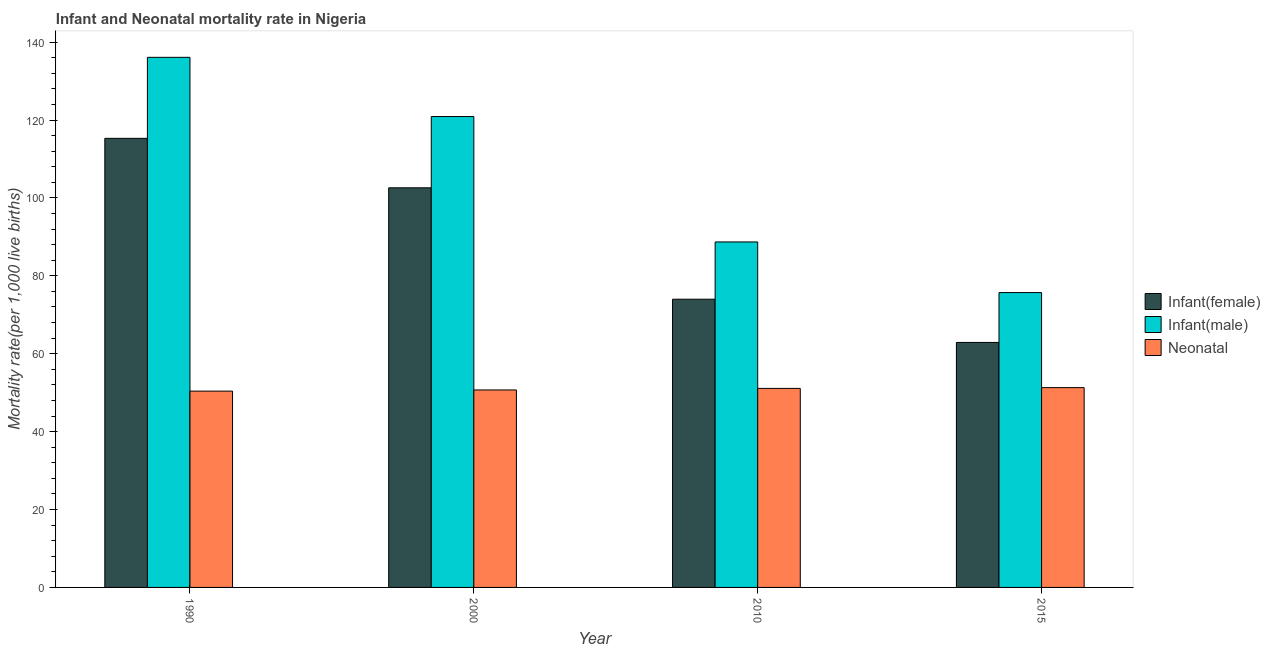How many different coloured bars are there?
Offer a very short reply. 3. How many groups of bars are there?
Ensure brevity in your answer.  4. Are the number of bars per tick equal to the number of legend labels?
Your answer should be very brief. Yes. Are the number of bars on each tick of the X-axis equal?
Provide a short and direct response. Yes. How many bars are there on the 3rd tick from the left?
Your response must be concise. 3. What is the infant mortality rate(female) in 2000?
Offer a very short reply. 102.6. Across all years, what is the maximum neonatal mortality rate?
Keep it short and to the point. 51.3. Across all years, what is the minimum infant mortality rate(male)?
Your response must be concise. 75.7. In which year was the infant mortality rate(female) minimum?
Offer a very short reply. 2015. What is the total infant mortality rate(female) in the graph?
Make the answer very short. 354.8. What is the difference between the infant mortality rate(female) in 2010 and that in 2015?
Ensure brevity in your answer.  11.1. What is the difference between the neonatal mortality rate in 2010 and the infant mortality rate(male) in 1990?
Keep it short and to the point. 0.7. What is the average infant mortality rate(female) per year?
Provide a short and direct response. 88.7. In the year 2015, what is the difference between the infant mortality rate(female) and neonatal mortality rate?
Your answer should be very brief. 0. In how many years, is the infant mortality rate(female) greater than 128?
Offer a very short reply. 0. What is the ratio of the infant mortality rate(male) in 1990 to that in 2010?
Your response must be concise. 1.53. What is the difference between the highest and the second highest infant mortality rate(male)?
Ensure brevity in your answer.  15.2. What is the difference between the highest and the lowest neonatal mortality rate?
Your answer should be compact. 0.9. What does the 2nd bar from the left in 2000 represents?
Keep it short and to the point. Infant(male). What does the 3rd bar from the right in 1990 represents?
Your answer should be compact. Infant(female). How many years are there in the graph?
Give a very brief answer. 4. Are the values on the major ticks of Y-axis written in scientific E-notation?
Your response must be concise. No. What is the title of the graph?
Make the answer very short. Infant and Neonatal mortality rate in Nigeria. Does "Fuel" appear as one of the legend labels in the graph?
Your response must be concise. No. What is the label or title of the Y-axis?
Give a very brief answer. Mortality rate(per 1,0 live births). What is the Mortality rate(per 1,000 live births) of Infant(female) in 1990?
Offer a terse response. 115.3. What is the Mortality rate(per 1,000 live births) of Infant(male) in 1990?
Provide a succinct answer. 136.1. What is the Mortality rate(per 1,000 live births) of Neonatal  in 1990?
Your answer should be compact. 50.4. What is the Mortality rate(per 1,000 live births) in Infant(female) in 2000?
Your answer should be very brief. 102.6. What is the Mortality rate(per 1,000 live births) in Infant(male) in 2000?
Provide a succinct answer. 120.9. What is the Mortality rate(per 1,000 live births) in Neonatal  in 2000?
Make the answer very short. 50.7. What is the Mortality rate(per 1,000 live births) in Infant(female) in 2010?
Offer a very short reply. 74. What is the Mortality rate(per 1,000 live births) in Infant(male) in 2010?
Your answer should be very brief. 88.7. What is the Mortality rate(per 1,000 live births) of Neonatal  in 2010?
Keep it short and to the point. 51.1. What is the Mortality rate(per 1,000 live births) in Infant(female) in 2015?
Provide a succinct answer. 62.9. What is the Mortality rate(per 1,000 live births) in Infant(male) in 2015?
Keep it short and to the point. 75.7. What is the Mortality rate(per 1,000 live births) of Neonatal  in 2015?
Your answer should be compact. 51.3. Across all years, what is the maximum Mortality rate(per 1,000 live births) in Infant(female)?
Offer a terse response. 115.3. Across all years, what is the maximum Mortality rate(per 1,000 live births) of Infant(male)?
Your answer should be compact. 136.1. Across all years, what is the maximum Mortality rate(per 1,000 live births) in Neonatal ?
Your response must be concise. 51.3. Across all years, what is the minimum Mortality rate(per 1,000 live births) of Infant(female)?
Keep it short and to the point. 62.9. Across all years, what is the minimum Mortality rate(per 1,000 live births) of Infant(male)?
Your answer should be compact. 75.7. Across all years, what is the minimum Mortality rate(per 1,000 live births) in Neonatal ?
Provide a succinct answer. 50.4. What is the total Mortality rate(per 1,000 live births) of Infant(female) in the graph?
Keep it short and to the point. 354.8. What is the total Mortality rate(per 1,000 live births) in Infant(male) in the graph?
Your answer should be very brief. 421.4. What is the total Mortality rate(per 1,000 live births) in Neonatal  in the graph?
Your answer should be compact. 203.5. What is the difference between the Mortality rate(per 1,000 live births) of Neonatal  in 1990 and that in 2000?
Offer a very short reply. -0.3. What is the difference between the Mortality rate(per 1,000 live births) in Infant(female) in 1990 and that in 2010?
Provide a short and direct response. 41.3. What is the difference between the Mortality rate(per 1,000 live births) of Infant(male) in 1990 and that in 2010?
Your answer should be compact. 47.4. What is the difference between the Mortality rate(per 1,000 live births) of Infant(female) in 1990 and that in 2015?
Your answer should be very brief. 52.4. What is the difference between the Mortality rate(per 1,000 live births) in Infant(male) in 1990 and that in 2015?
Offer a terse response. 60.4. What is the difference between the Mortality rate(per 1,000 live births) in Infant(female) in 2000 and that in 2010?
Provide a short and direct response. 28.6. What is the difference between the Mortality rate(per 1,000 live births) of Infant(male) in 2000 and that in 2010?
Your response must be concise. 32.2. What is the difference between the Mortality rate(per 1,000 live births) in Infant(female) in 2000 and that in 2015?
Keep it short and to the point. 39.7. What is the difference between the Mortality rate(per 1,000 live births) of Infant(male) in 2000 and that in 2015?
Keep it short and to the point. 45.2. What is the difference between the Mortality rate(per 1,000 live births) in Infant(female) in 2010 and that in 2015?
Offer a terse response. 11.1. What is the difference between the Mortality rate(per 1,000 live births) in Infant(male) in 2010 and that in 2015?
Your response must be concise. 13. What is the difference between the Mortality rate(per 1,000 live births) in Neonatal  in 2010 and that in 2015?
Your response must be concise. -0.2. What is the difference between the Mortality rate(per 1,000 live births) in Infant(female) in 1990 and the Mortality rate(per 1,000 live births) in Infant(male) in 2000?
Your response must be concise. -5.6. What is the difference between the Mortality rate(per 1,000 live births) of Infant(female) in 1990 and the Mortality rate(per 1,000 live births) of Neonatal  in 2000?
Keep it short and to the point. 64.6. What is the difference between the Mortality rate(per 1,000 live births) of Infant(male) in 1990 and the Mortality rate(per 1,000 live births) of Neonatal  in 2000?
Keep it short and to the point. 85.4. What is the difference between the Mortality rate(per 1,000 live births) of Infant(female) in 1990 and the Mortality rate(per 1,000 live births) of Infant(male) in 2010?
Provide a short and direct response. 26.6. What is the difference between the Mortality rate(per 1,000 live births) of Infant(female) in 1990 and the Mortality rate(per 1,000 live births) of Neonatal  in 2010?
Your answer should be very brief. 64.2. What is the difference between the Mortality rate(per 1,000 live births) of Infant(female) in 1990 and the Mortality rate(per 1,000 live births) of Infant(male) in 2015?
Ensure brevity in your answer.  39.6. What is the difference between the Mortality rate(per 1,000 live births) in Infant(male) in 1990 and the Mortality rate(per 1,000 live births) in Neonatal  in 2015?
Keep it short and to the point. 84.8. What is the difference between the Mortality rate(per 1,000 live births) of Infant(female) in 2000 and the Mortality rate(per 1,000 live births) of Infant(male) in 2010?
Provide a succinct answer. 13.9. What is the difference between the Mortality rate(per 1,000 live births) in Infant(female) in 2000 and the Mortality rate(per 1,000 live births) in Neonatal  in 2010?
Make the answer very short. 51.5. What is the difference between the Mortality rate(per 1,000 live births) in Infant(male) in 2000 and the Mortality rate(per 1,000 live births) in Neonatal  in 2010?
Your answer should be compact. 69.8. What is the difference between the Mortality rate(per 1,000 live births) in Infant(female) in 2000 and the Mortality rate(per 1,000 live births) in Infant(male) in 2015?
Give a very brief answer. 26.9. What is the difference between the Mortality rate(per 1,000 live births) of Infant(female) in 2000 and the Mortality rate(per 1,000 live births) of Neonatal  in 2015?
Offer a terse response. 51.3. What is the difference between the Mortality rate(per 1,000 live births) in Infant(male) in 2000 and the Mortality rate(per 1,000 live births) in Neonatal  in 2015?
Give a very brief answer. 69.6. What is the difference between the Mortality rate(per 1,000 live births) of Infant(female) in 2010 and the Mortality rate(per 1,000 live births) of Infant(male) in 2015?
Provide a succinct answer. -1.7. What is the difference between the Mortality rate(per 1,000 live births) of Infant(female) in 2010 and the Mortality rate(per 1,000 live births) of Neonatal  in 2015?
Ensure brevity in your answer.  22.7. What is the difference between the Mortality rate(per 1,000 live births) of Infant(male) in 2010 and the Mortality rate(per 1,000 live births) of Neonatal  in 2015?
Give a very brief answer. 37.4. What is the average Mortality rate(per 1,000 live births) of Infant(female) per year?
Your answer should be compact. 88.7. What is the average Mortality rate(per 1,000 live births) of Infant(male) per year?
Offer a terse response. 105.35. What is the average Mortality rate(per 1,000 live births) in Neonatal  per year?
Offer a terse response. 50.88. In the year 1990, what is the difference between the Mortality rate(per 1,000 live births) of Infant(female) and Mortality rate(per 1,000 live births) of Infant(male)?
Ensure brevity in your answer.  -20.8. In the year 1990, what is the difference between the Mortality rate(per 1,000 live births) of Infant(female) and Mortality rate(per 1,000 live births) of Neonatal ?
Your response must be concise. 64.9. In the year 1990, what is the difference between the Mortality rate(per 1,000 live births) of Infant(male) and Mortality rate(per 1,000 live births) of Neonatal ?
Your response must be concise. 85.7. In the year 2000, what is the difference between the Mortality rate(per 1,000 live births) in Infant(female) and Mortality rate(per 1,000 live births) in Infant(male)?
Offer a terse response. -18.3. In the year 2000, what is the difference between the Mortality rate(per 1,000 live births) in Infant(female) and Mortality rate(per 1,000 live births) in Neonatal ?
Provide a short and direct response. 51.9. In the year 2000, what is the difference between the Mortality rate(per 1,000 live births) in Infant(male) and Mortality rate(per 1,000 live births) in Neonatal ?
Your response must be concise. 70.2. In the year 2010, what is the difference between the Mortality rate(per 1,000 live births) of Infant(female) and Mortality rate(per 1,000 live births) of Infant(male)?
Your answer should be very brief. -14.7. In the year 2010, what is the difference between the Mortality rate(per 1,000 live births) in Infant(female) and Mortality rate(per 1,000 live births) in Neonatal ?
Make the answer very short. 22.9. In the year 2010, what is the difference between the Mortality rate(per 1,000 live births) in Infant(male) and Mortality rate(per 1,000 live births) in Neonatal ?
Ensure brevity in your answer.  37.6. In the year 2015, what is the difference between the Mortality rate(per 1,000 live births) of Infant(male) and Mortality rate(per 1,000 live births) of Neonatal ?
Ensure brevity in your answer.  24.4. What is the ratio of the Mortality rate(per 1,000 live births) in Infant(female) in 1990 to that in 2000?
Ensure brevity in your answer.  1.12. What is the ratio of the Mortality rate(per 1,000 live births) in Infant(male) in 1990 to that in 2000?
Your answer should be compact. 1.13. What is the ratio of the Mortality rate(per 1,000 live births) of Infant(female) in 1990 to that in 2010?
Ensure brevity in your answer.  1.56. What is the ratio of the Mortality rate(per 1,000 live births) in Infant(male) in 1990 to that in 2010?
Give a very brief answer. 1.53. What is the ratio of the Mortality rate(per 1,000 live births) of Neonatal  in 1990 to that in 2010?
Provide a short and direct response. 0.99. What is the ratio of the Mortality rate(per 1,000 live births) of Infant(female) in 1990 to that in 2015?
Offer a terse response. 1.83. What is the ratio of the Mortality rate(per 1,000 live births) of Infant(male) in 1990 to that in 2015?
Provide a short and direct response. 1.8. What is the ratio of the Mortality rate(per 1,000 live births) in Neonatal  in 1990 to that in 2015?
Offer a very short reply. 0.98. What is the ratio of the Mortality rate(per 1,000 live births) in Infant(female) in 2000 to that in 2010?
Your response must be concise. 1.39. What is the ratio of the Mortality rate(per 1,000 live births) in Infant(male) in 2000 to that in 2010?
Your answer should be very brief. 1.36. What is the ratio of the Mortality rate(per 1,000 live births) in Neonatal  in 2000 to that in 2010?
Your answer should be very brief. 0.99. What is the ratio of the Mortality rate(per 1,000 live births) in Infant(female) in 2000 to that in 2015?
Your answer should be very brief. 1.63. What is the ratio of the Mortality rate(per 1,000 live births) of Infant(male) in 2000 to that in 2015?
Your answer should be compact. 1.6. What is the ratio of the Mortality rate(per 1,000 live births) of Neonatal  in 2000 to that in 2015?
Give a very brief answer. 0.99. What is the ratio of the Mortality rate(per 1,000 live births) in Infant(female) in 2010 to that in 2015?
Provide a succinct answer. 1.18. What is the ratio of the Mortality rate(per 1,000 live births) of Infant(male) in 2010 to that in 2015?
Your response must be concise. 1.17. What is the difference between the highest and the second highest Mortality rate(per 1,000 live births) in Infant(female)?
Your answer should be compact. 12.7. What is the difference between the highest and the second highest Mortality rate(per 1,000 live births) of Infant(male)?
Ensure brevity in your answer.  15.2. What is the difference between the highest and the second highest Mortality rate(per 1,000 live births) of Neonatal ?
Offer a terse response. 0.2. What is the difference between the highest and the lowest Mortality rate(per 1,000 live births) of Infant(female)?
Keep it short and to the point. 52.4. What is the difference between the highest and the lowest Mortality rate(per 1,000 live births) in Infant(male)?
Provide a succinct answer. 60.4. What is the difference between the highest and the lowest Mortality rate(per 1,000 live births) in Neonatal ?
Give a very brief answer. 0.9. 